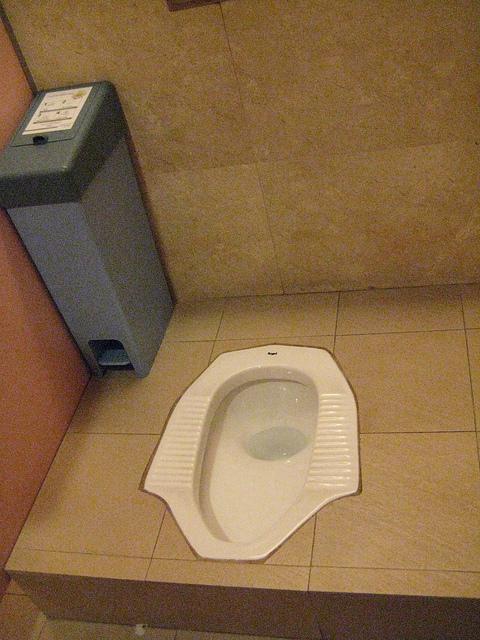Is this a popular toilet in the USA?
Write a very short answer. No. Can you sit on this toilet?
Give a very brief answer. No. What is next to the toilet?
Quick response, please. Trash can. 